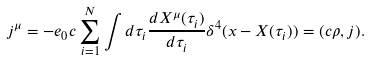<formula> <loc_0><loc_0><loc_500><loc_500>j ^ { \mu } = - e _ { 0 } c \sum _ { i = 1 } ^ { N } \int d \tau _ { i } \frac { d X ^ { \mu } ( \tau _ { i } ) } { d \tau _ { i } } \delta ^ { 4 } ( x - X ( \tau _ { i } ) ) = ( c \rho , j ) .</formula> 